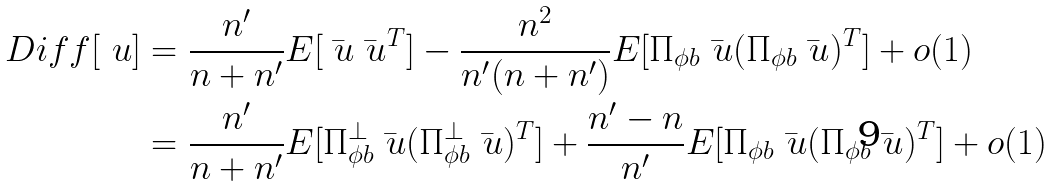<formula> <loc_0><loc_0><loc_500><loc_500>D i f f [ \ u ] & = \frac { n ^ { \prime } } { n + n ^ { \prime } } E [ \bar { \ u } \bar { \ u } ^ { T } ] - \frac { n ^ { 2 } } { n ^ { \prime } ( n + n ^ { \prime } ) } E [ \Pi _ { \phi b } \bar { \ u } ( \Pi _ { \phi b } \bar { \ u } ) ^ { T } ] + o ( 1 ) \\ & = \frac { n ^ { \prime } } { n + n ^ { \prime } } E [ { \Pi _ { \phi b } ^ { \bot } } \bar { \ u } ( { \Pi _ { \phi b } ^ { \bot } } \bar { \ u } ) ^ { T } ] + \frac { n ^ { \prime } - n } { n ^ { \prime } } E [ { \Pi _ { \phi b } } \bar { \ u } ( { \Pi _ { \phi b } } \bar { \ u } ) ^ { T } ] + o ( 1 )</formula> 